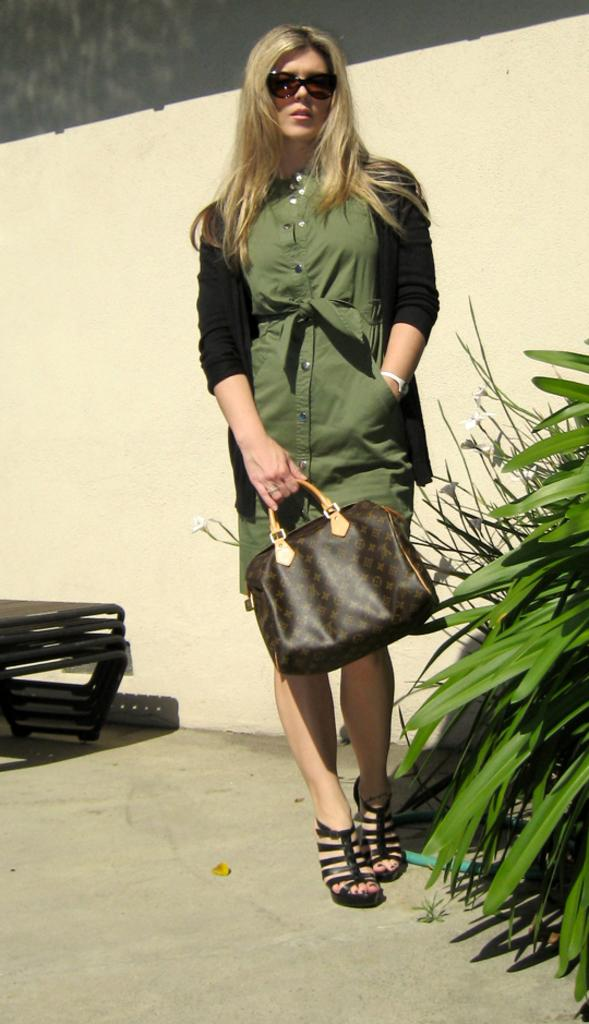What is the main subject of the image? There is a person standing in the image. What is the person holding in her hand? The person is holding a bag in her hand. What type of vegetation can be seen on the right side of the image? There are plants on the right side of the image. What is visible behind the person? There is a wall visible behind the person. What type of fruit is the bear eating in the image? There is no bear or fruit present in the image. What is the floor made of in the image? The image does not show the floor, so it cannot be determined what material it is made of. 